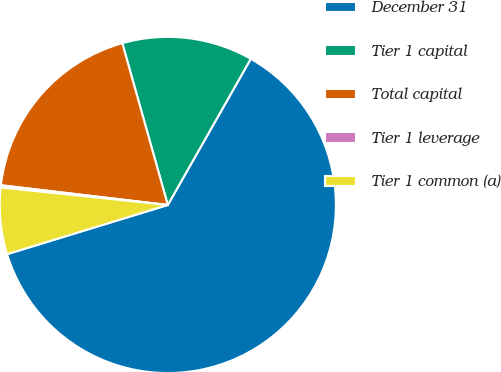Convert chart to OTSL. <chart><loc_0><loc_0><loc_500><loc_500><pie_chart><fcel>December 31<fcel>Tier 1 capital<fcel>Total capital<fcel>Tier 1 leverage<fcel>Tier 1 common (a)<nl><fcel>62.05%<fcel>12.58%<fcel>18.76%<fcel>0.21%<fcel>6.39%<nl></chart> 